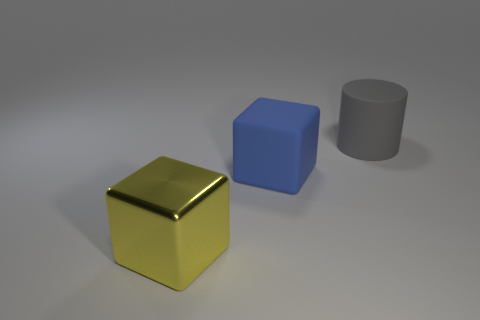Add 2 yellow objects. How many objects exist? 5 Subtract all cylinders. How many objects are left? 2 Subtract 1 gray cylinders. How many objects are left? 2 Subtract all matte blocks. Subtract all gray rubber cylinders. How many objects are left? 1 Add 2 large blue objects. How many large blue objects are left? 3 Add 2 rubber blocks. How many rubber blocks exist? 3 